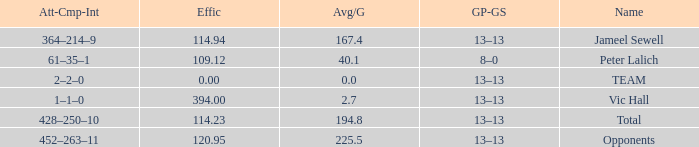Avg/G that has a GP-GS of 13–13, and a Effic smaller than 114.23 has what total of numbers? 1.0. 